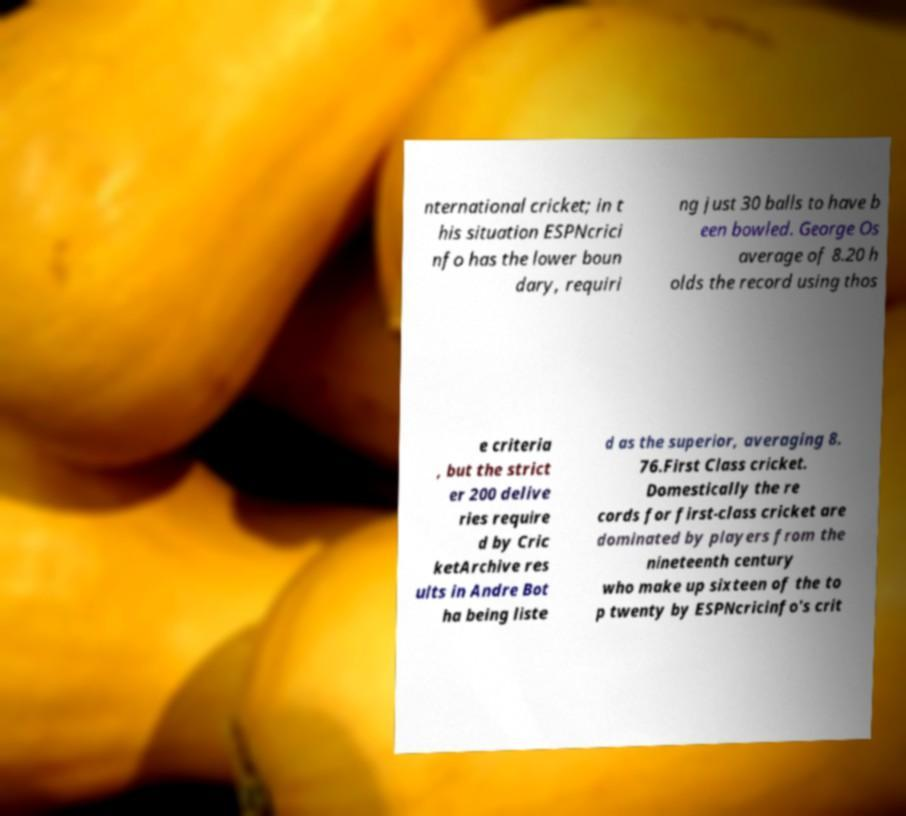I need the written content from this picture converted into text. Can you do that? nternational cricket; in t his situation ESPNcrici nfo has the lower boun dary, requiri ng just 30 balls to have b een bowled. George Os average of 8.20 h olds the record using thos e criteria , but the strict er 200 delive ries require d by Cric ketArchive res ults in Andre Bot ha being liste d as the superior, averaging 8. 76.First Class cricket. Domestically the re cords for first-class cricket are dominated by players from the nineteenth century who make up sixteen of the to p twenty by ESPNcricinfo's crit 